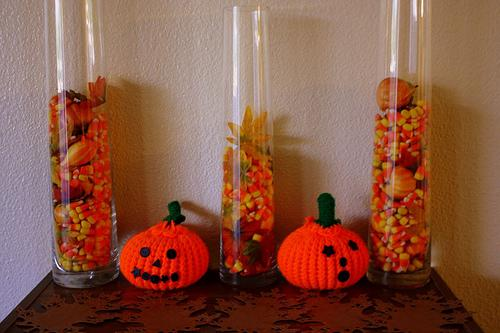Question: where was the photo taken?
Choices:
A. Theme park.
B. Living room.
C. Near a table.
D. Den.
Answer with the letter. Answer: C Question: what is in the photo?
Choices:
A. Decorations.
B. Sunset.
C. Skyline.
D. Food.
Answer with the letter. Answer: A Question: who is in the photo?
Choices:
A. My mother.
B. My brother.
C. My coworkers.
D. No one.
Answer with the letter. Answer: D 